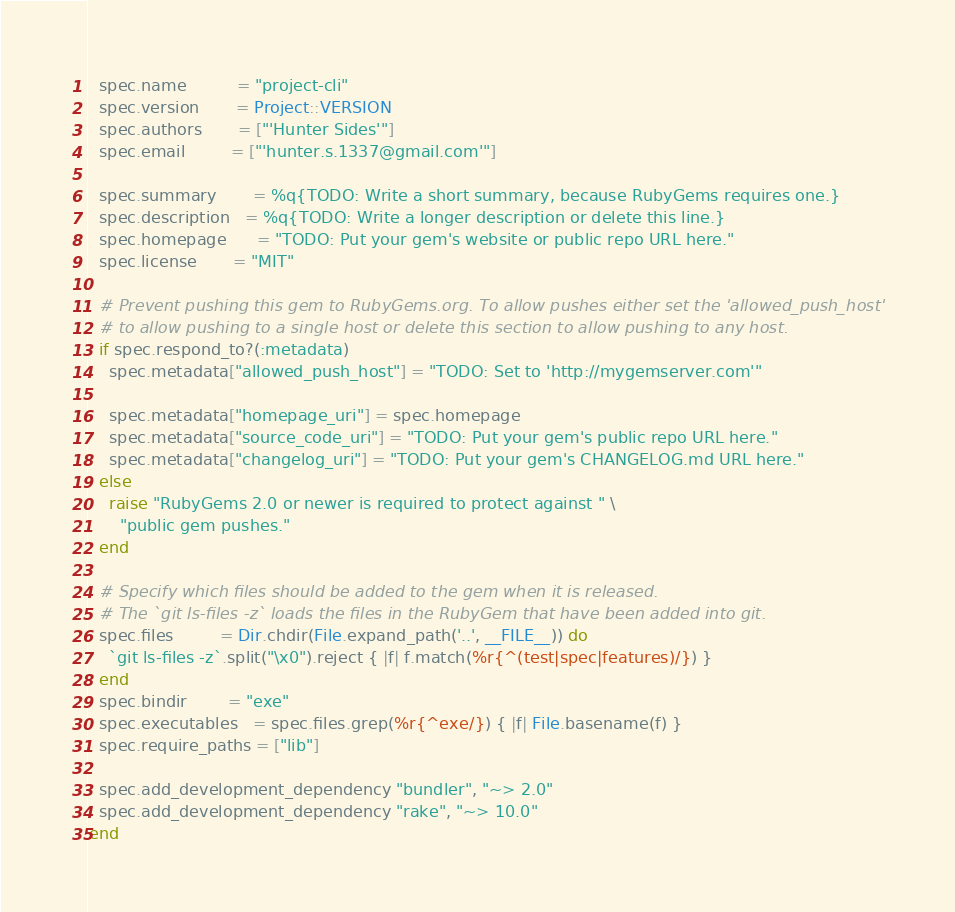<code> <loc_0><loc_0><loc_500><loc_500><_Ruby_>  spec.name          = "project-cli"
  spec.version       = Project::VERSION
  spec.authors       = ["'Hunter Sides'"]
  spec.email         = ["'hunter.s.1337@gmail.com'"]

  spec.summary       = %q{TODO: Write a short summary, because RubyGems requires one.}
  spec.description   = %q{TODO: Write a longer description or delete this line.}
  spec.homepage      = "TODO: Put your gem's website or public repo URL here."
  spec.license       = "MIT"

  # Prevent pushing this gem to RubyGems.org. To allow pushes either set the 'allowed_push_host'
  # to allow pushing to a single host or delete this section to allow pushing to any host.
  if spec.respond_to?(:metadata)
    spec.metadata["allowed_push_host"] = "TODO: Set to 'http://mygemserver.com'"

    spec.metadata["homepage_uri"] = spec.homepage
    spec.metadata["source_code_uri"] = "TODO: Put your gem's public repo URL here."
    spec.metadata["changelog_uri"] = "TODO: Put your gem's CHANGELOG.md URL here."
  else
    raise "RubyGems 2.0 or newer is required to protect against " \
      "public gem pushes."
  end

  # Specify which files should be added to the gem when it is released.
  # The `git ls-files -z` loads the files in the RubyGem that have been added into git.
  spec.files         = Dir.chdir(File.expand_path('..', __FILE__)) do
    `git ls-files -z`.split("\x0").reject { |f| f.match(%r{^(test|spec|features)/}) }
  end
  spec.bindir        = "exe"
  spec.executables   = spec.files.grep(%r{^exe/}) { |f| File.basename(f) }
  spec.require_paths = ["lib"]

  spec.add_development_dependency "bundler", "~> 2.0"
  spec.add_development_dependency "rake", "~> 10.0"
end
</code> 